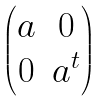<formula> <loc_0><loc_0><loc_500><loc_500>\begin{pmatrix} a & 0 \\ 0 & a ^ { t } \end{pmatrix}</formula> 